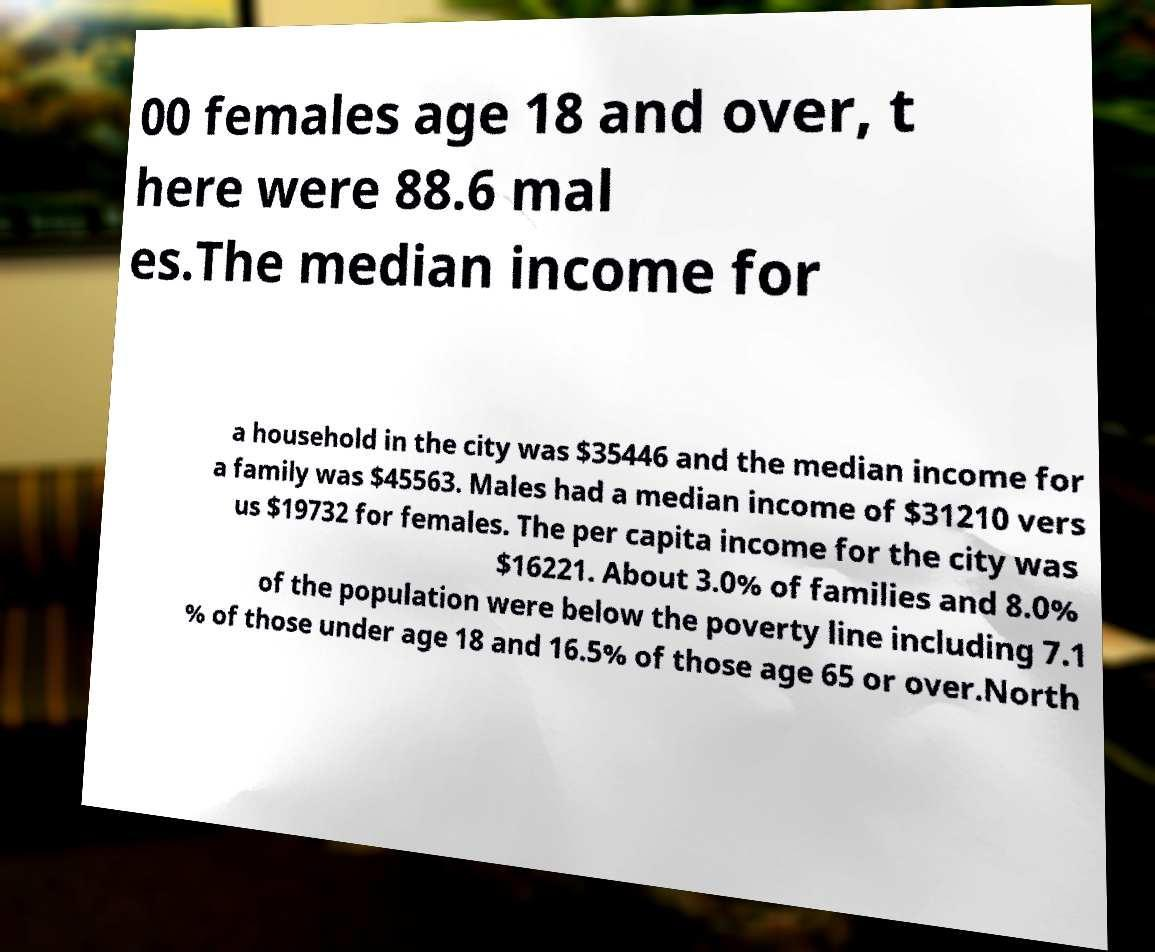Can you accurately transcribe the text from the provided image for me? 00 females age 18 and over, t here were 88.6 mal es.The median income for a household in the city was $35446 and the median income for a family was $45563. Males had a median income of $31210 vers us $19732 for females. The per capita income for the city was $16221. About 3.0% of families and 8.0% of the population were below the poverty line including 7.1 % of those under age 18 and 16.5% of those age 65 or over.North 